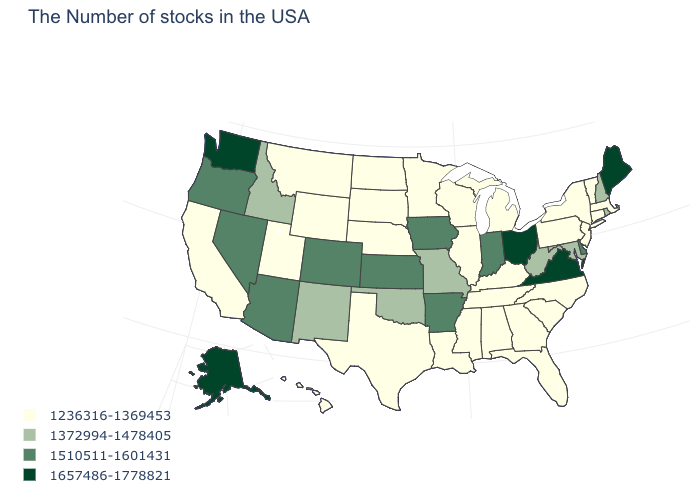What is the value of Utah?
Keep it brief. 1236316-1369453. How many symbols are there in the legend?
Give a very brief answer. 4. What is the value of Alabama?
Quick response, please. 1236316-1369453. What is the value of Iowa?
Quick response, please. 1510511-1601431. Which states have the lowest value in the USA?
Quick response, please. Massachusetts, Vermont, Connecticut, New York, New Jersey, Pennsylvania, North Carolina, South Carolina, Florida, Georgia, Michigan, Kentucky, Alabama, Tennessee, Wisconsin, Illinois, Mississippi, Louisiana, Minnesota, Nebraska, Texas, South Dakota, North Dakota, Wyoming, Utah, Montana, California, Hawaii. What is the value of Maine?
Short answer required. 1657486-1778821. Does Maryland have a lower value than Washington?
Keep it brief. Yes. Name the states that have a value in the range 1510511-1601431?
Give a very brief answer. Delaware, Indiana, Arkansas, Iowa, Kansas, Colorado, Arizona, Nevada, Oregon. What is the lowest value in the South?
Short answer required. 1236316-1369453. What is the highest value in states that border Minnesota?
Write a very short answer. 1510511-1601431. Does Nebraska have the same value as New Hampshire?
Answer briefly. No. What is the highest value in the USA?
Short answer required. 1657486-1778821. What is the lowest value in states that border Delaware?
Concise answer only. 1236316-1369453. Which states have the lowest value in the USA?
Keep it brief. Massachusetts, Vermont, Connecticut, New York, New Jersey, Pennsylvania, North Carolina, South Carolina, Florida, Georgia, Michigan, Kentucky, Alabama, Tennessee, Wisconsin, Illinois, Mississippi, Louisiana, Minnesota, Nebraska, Texas, South Dakota, North Dakota, Wyoming, Utah, Montana, California, Hawaii. Does the map have missing data?
Keep it brief. No. 